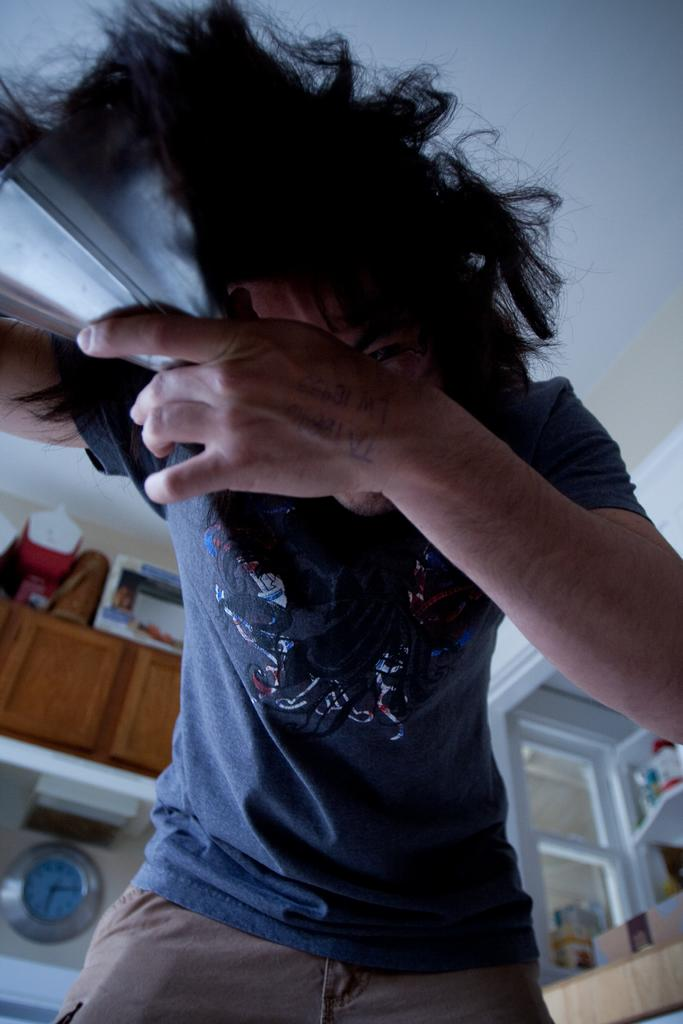Who or what is present in the image? There is a person in the image. What can be seen in the background of the image? In the background of the image, there are cupboards, boxes, a clock, a wall, and other unspecified objects. Can you describe the objects in the background? The background of the image features cupboards, boxes, a clock, and a wall. What might be the purpose of the clock in the image? The clock in the background of the image could be used to tell time or serve as a decorative element. What type of cannon is being offered by the person in the image? There is no cannon present in the image, and the person is not offering anything. 